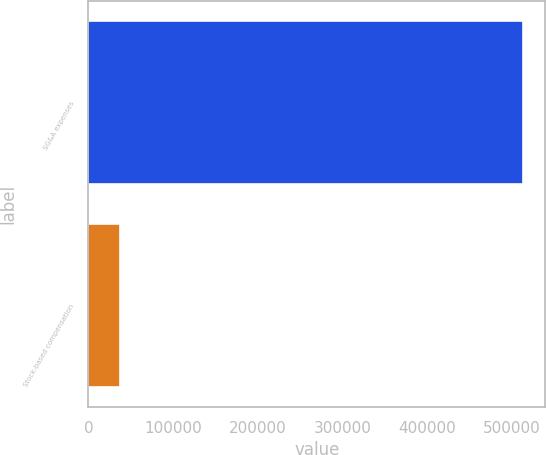Convert chart to OTSL. <chart><loc_0><loc_0><loc_500><loc_500><bar_chart><fcel>SG&A expenses<fcel>Stock-based compensation<nl><fcel>513525<fcel>37164<nl></chart> 